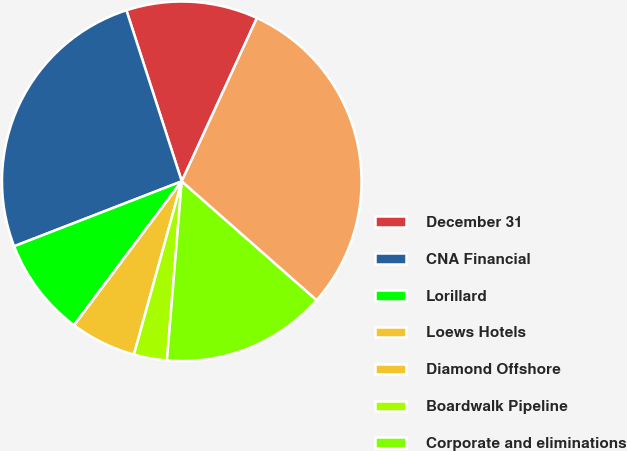Convert chart to OTSL. <chart><loc_0><loc_0><loc_500><loc_500><pie_chart><fcel>December 31<fcel>CNA Financial<fcel>Lorillard<fcel>Loews Hotels<fcel>Diamond Offshore<fcel>Boardwalk Pipeline<fcel>Corporate and eliminations<fcel>Total<nl><fcel>11.85%<fcel>25.9%<fcel>8.89%<fcel>0.01%<fcel>5.93%<fcel>2.97%<fcel>14.82%<fcel>29.63%<nl></chart> 